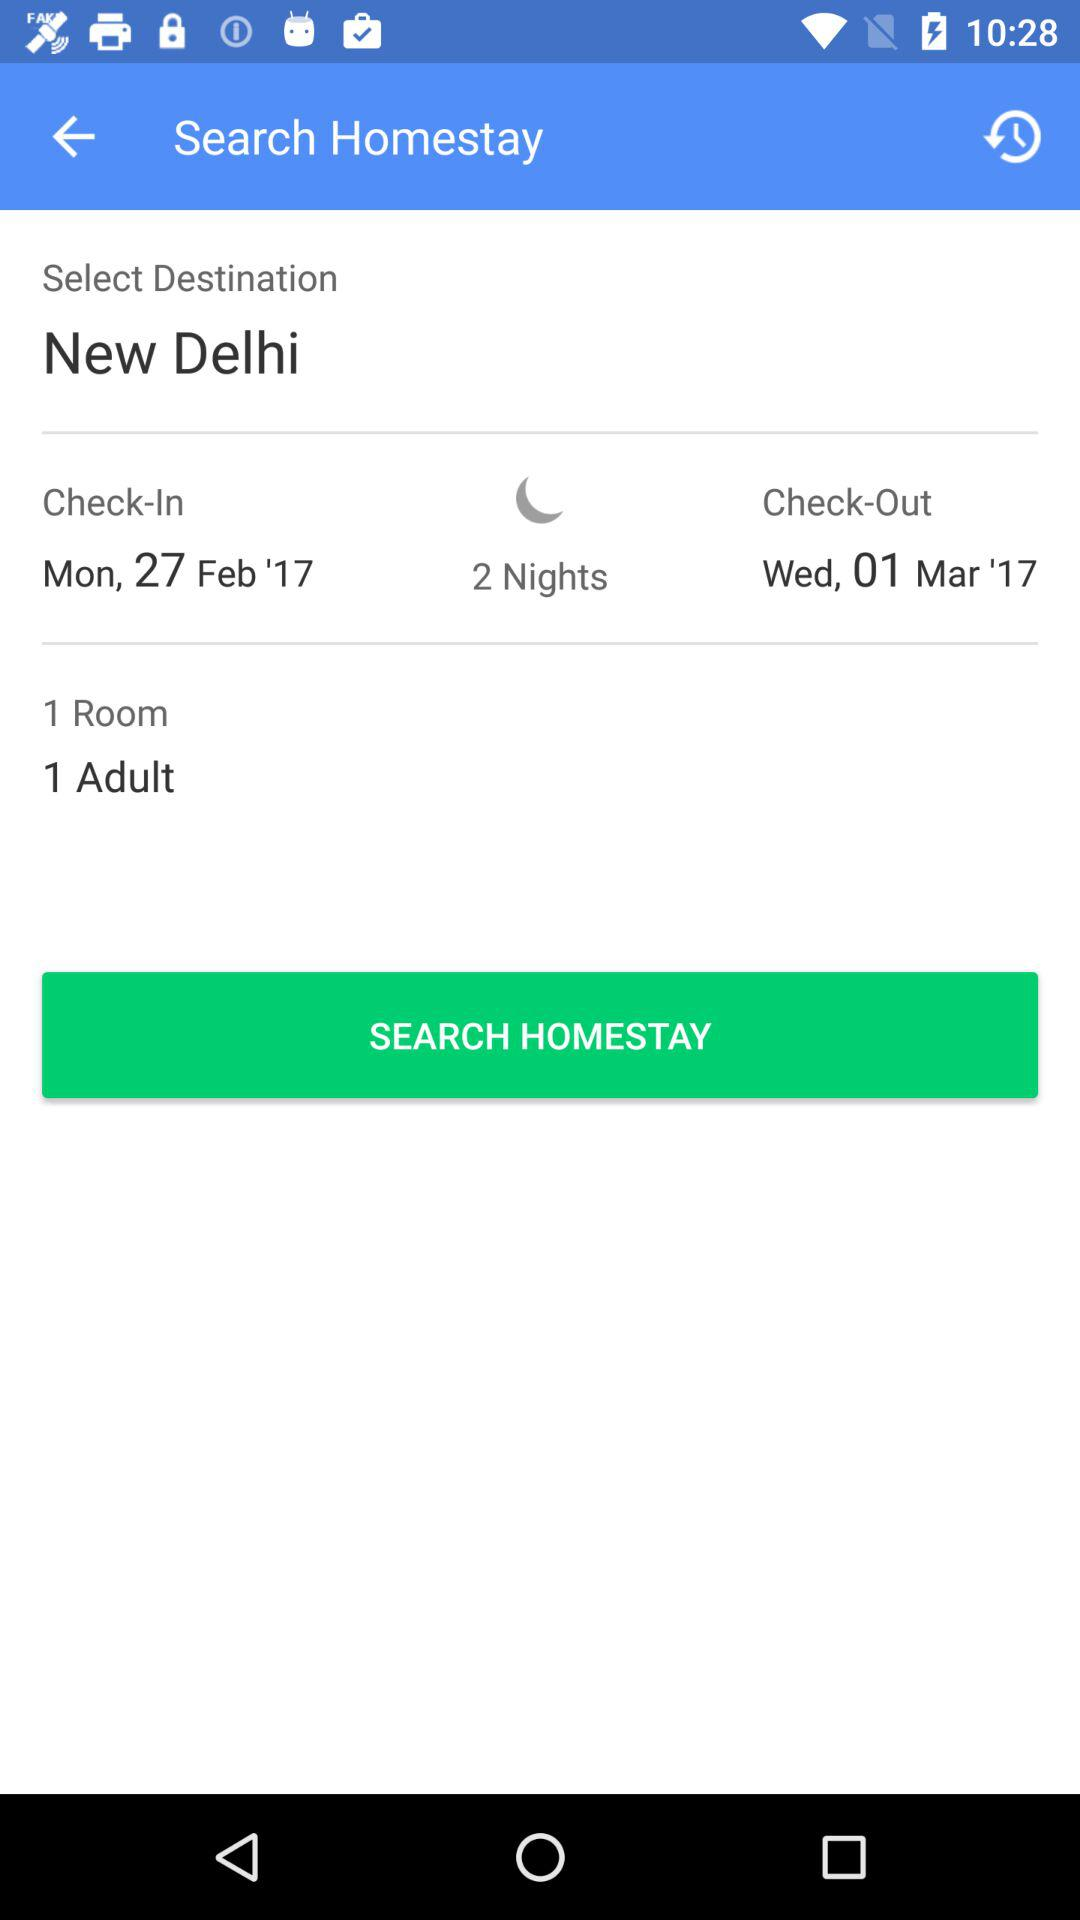What is the check-in date? The check-in date is Monday, February 27, 2017. 